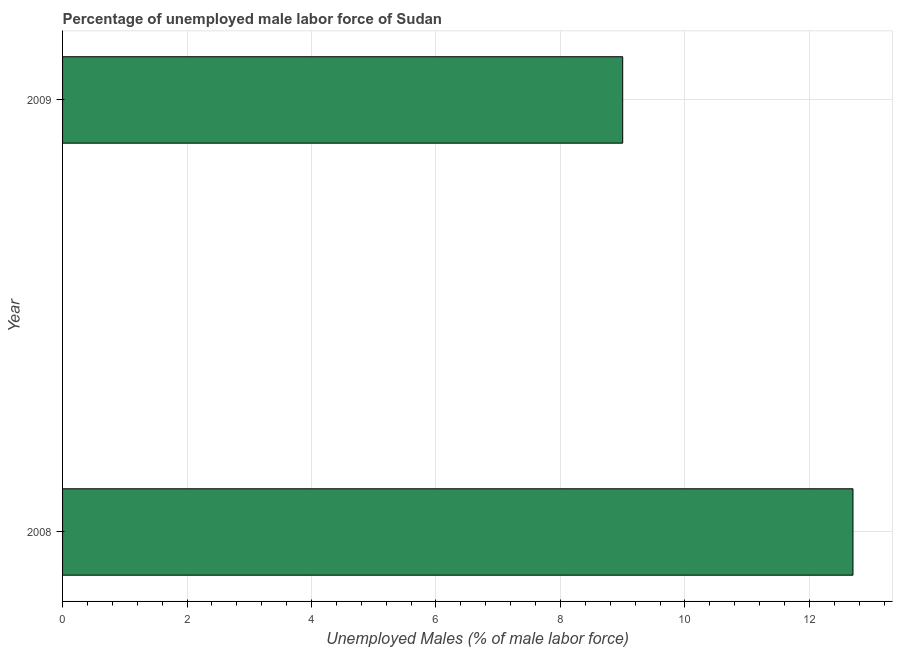What is the title of the graph?
Your response must be concise. Percentage of unemployed male labor force of Sudan. What is the label or title of the X-axis?
Ensure brevity in your answer.  Unemployed Males (% of male labor force). What is the label or title of the Y-axis?
Provide a short and direct response. Year. What is the total unemployed male labour force in 2008?
Ensure brevity in your answer.  12.7. Across all years, what is the maximum total unemployed male labour force?
Make the answer very short. 12.7. What is the sum of the total unemployed male labour force?
Keep it short and to the point. 21.7. What is the difference between the total unemployed male labour force in 2008 and 2009?
Your answer should be very brief. 3.7. What is the average total unemployed male labour force per year?
Provide a short and direct response. 10.85. What is the median total unemployed male labour force?
Your answer should be compact. 10.85. In how many years, is the total unemployed male labour force greater than 7.6 %?
Give a very brief answer. 2. Do a majority of the years between 2008 and 2009 (inclusive) have total unemployed male labour force greater than 6.4 %?
Offer a very short reply. Yes. What is the ratio of the total unemployed male labour force in 2008 to that in 2009?
Provide a succinct answer. 1.41. Is the total unemployed male labour force in 2008 less than that in 2009?
Provide a succinct answer. No. Are all the bars in the graph horizontal?
Give a very brief answer. Yes. Are the values on the major ticks of X-axis written in scientific E-notation?
Your answer should be compact. No. What is the Unemployed Males (% of male labor force) of 2008?
Provide a succinct answer. 12.7. What is the Unemployed Males (% of male labor force) in 2009?
Your response must be concise. 9. What is the difference between the Unemployed Males (% of male labor force) in 2008 and 2009?
Provide a succinct answer. 3.7. What is the ratio of the Unemployed Males (% of male labor force) in 2008 to that in 2009?
Ensure brevity in your answer.  1.41. 